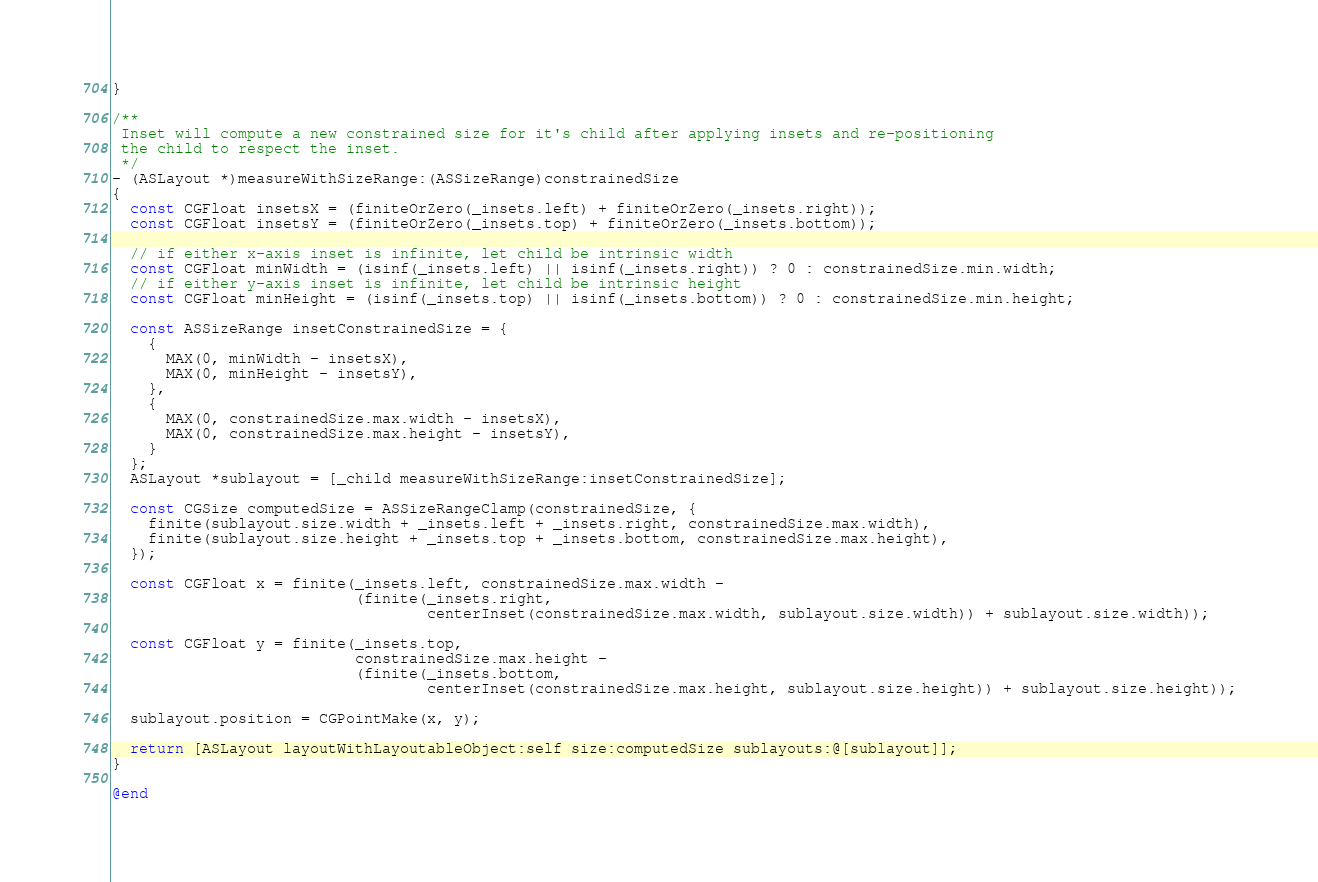Convert code to text. <code><loc_0><loc_0><loc_500><loc_500><_ObjectiveC_>}

/**
 Inset will compute a new constrained size for it's child after applying insets and re-positioning
 the child to respect the inset.
 */
- (ASLayout *)measureWithSizeRange:(ASSizeRange)constrainedSize
{
  const CGFloat insetsX = (finiteOrZero(_insets.left) + finiteOrZero(_insets.right));
  const CGFloat insetsY = (finiteOrZero(_insets.top) + finiteOrZero(_insets.bottom));

  // if either x-axis inset is infinite, let child be intrinsic width
  const CGFloat minWidth = (isinf(_insets.left) || isinf(_insets.right)) ? 0 : constrainedSize.min.width;
  // if either y-axis inset is infinite, let child be intrinsic height
  const CGFloat minHeight = (isinf(_insets.top) || isinf(_insets.bottom)) ? 0 : constrainedSize.min.height;

  const ASSizeRange insetConstrainedSize = {
    {
      MAX(0, minWidth - insetsX),
      MAX(0, minHeight - insetsY),
    },
    {
      MAX(0, constrainedSize.max.width - insetsX),
      MAX(0, constrainedSize.max.height - insetsY),
    }
  };
  ASLayout *sublayout = [_child measureWithSizeRange:insetConstrainedSize];

  const CGSize computedSize = ASSizeRangeClamp(constrainedSize, {
    finite(sublayout.size.width + _insets.left + _insets.right, constrainedSize.max.width),
    finite(sublayout.size.height + _insets.top + _insets.bottom, constrainedSize.max.height),
  });

  const CGFloat x = finite(_insets.left, constrainedSize.max.width -
                           (finite(_insets.right,
                                   centerInset(constrainedSize.max.width, sublayout.size.width)) + sublayout.size.width));

  const CGFloat y = finite(_insets.top,
                           constrainedSize.max.height -
                           (finite(_insets.bottom,
                                   centerInset(constrainedSize.max.height, sublayout.size.height)) + sublayout.size.height));
  
  sublayout.position = CGPointMake(x, y);
  
  return [ASLayout layoutWithLayoutableObject:self size:computedSize sublayouts:@[sublayout]];
}

@end
</code> 